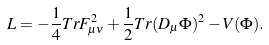Convert formula to latex. <formula><loc_0><loc_0><loc_500><loc_500>L = - \frac { 1 } { 4 } T r F _ { \mu \nu } ^ { 2 } + \frac { 1 } { 2 } T r ( D _ { \mu } \Phi ) ^ { 2 } - V ( \Phi ) .</formula> 